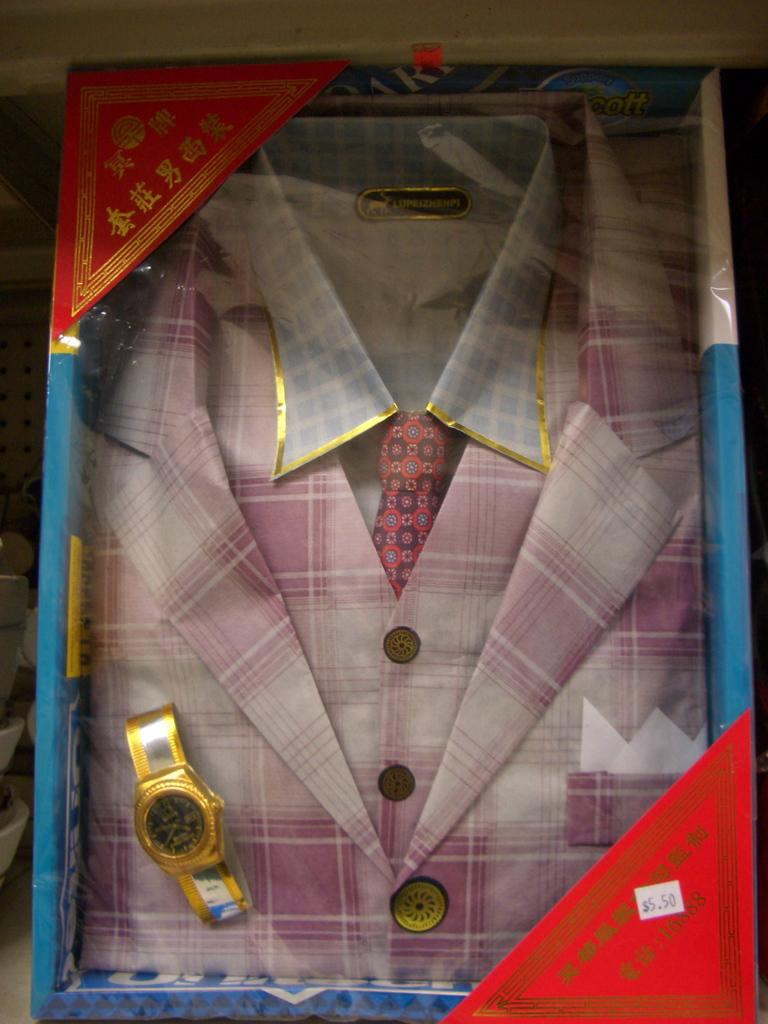<image>
Offer a succinct explanation of the picture presented. The price on the clothing in the box is 5.50 